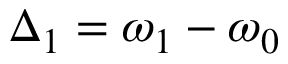<formula> <loc_0><loc_0><loc_500><loc_500>\Delta _ { 1 } = \omega _ { 1 } - \omega _ { 0 }</formula> 